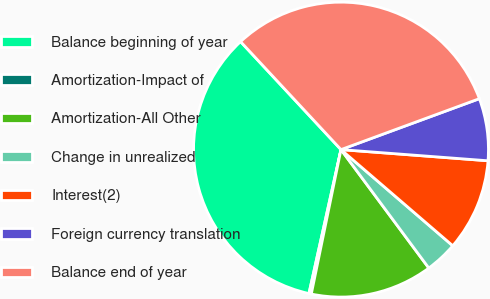Convert chart to OTSL. <chart><loc_0><loc_0><loc_500><loc_500><pie_chart><fcel>Balance beginning of year<fcel>Amortization-Impact of<fcel>Amortization-All Other<fcel>Change in unrealized<fcel>Interest(2)<fcel>Foreign currency translation<fcel>Balance end of year<nl><fcel>34.59%<fcel>0.26%<fcel>13.38%<fcel>3.54%<fcel>10.1%<fcel>6.82%<fcel>31.31%<nl></chart> 